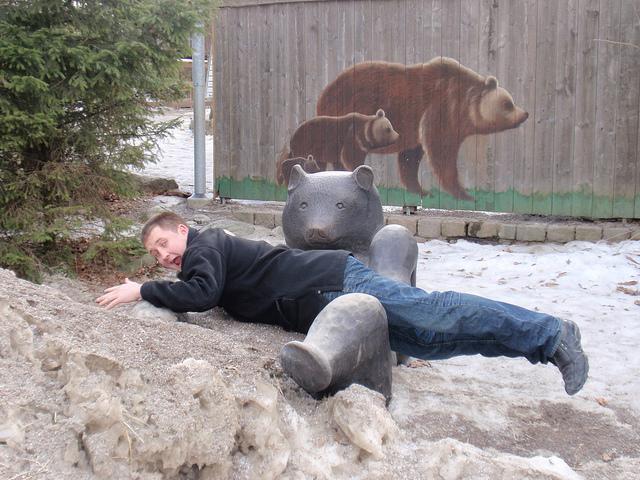How many bears are visible?
Give a very brief answer. 2. 